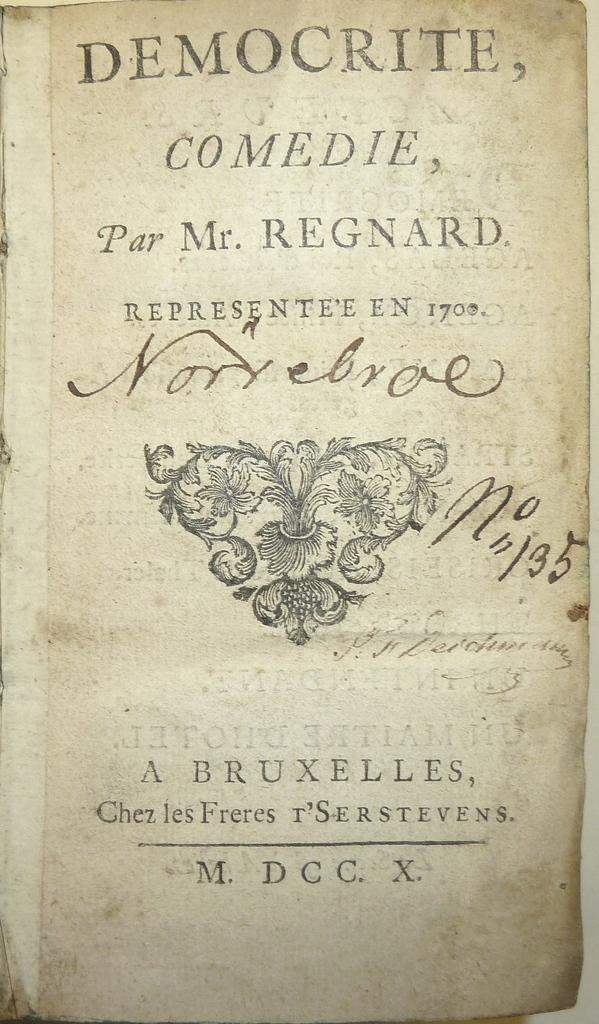<image>
Relay a brief, clear account of the picture shown. An exceptionally old copy of Democrite, Comedie, Par Mr. Regnard. 